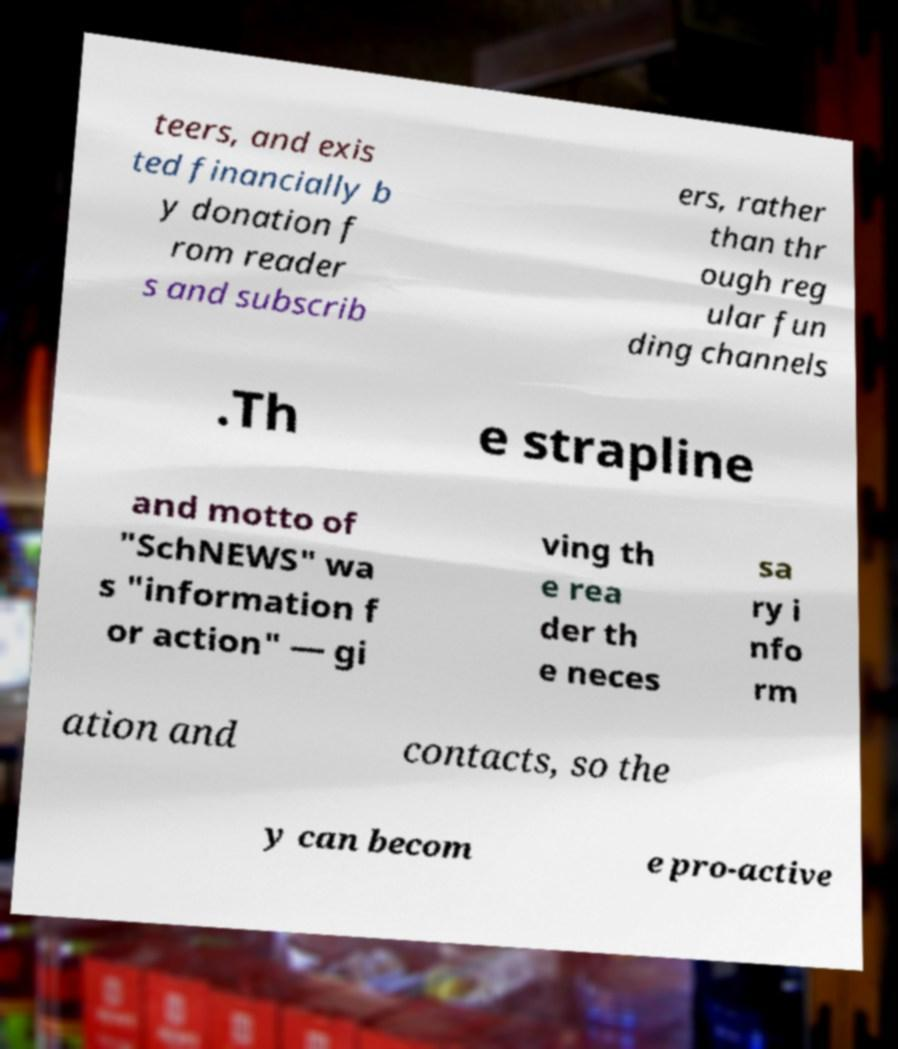Please identify and transcribe the text found in this image. teers, and exis ted financially b y donation f rom reader s and subscrib ers, rather than thr ough reg ular fun ding channels .Th e strapline and motto of "SchNEWS" wa s "information f or action" — gi ving th e rea der th e neces sa ry i nfo rm ation and contacts, so the y can becom e pro-active 